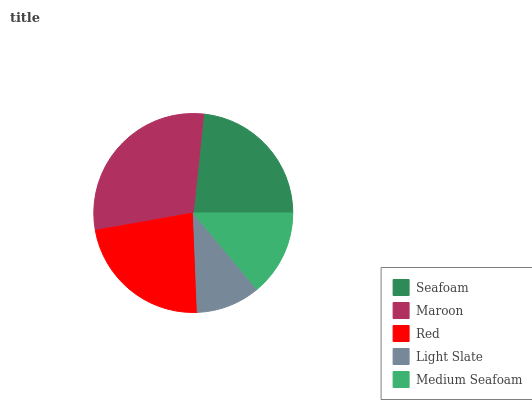Is Light Slate the minimum?
Answer yes or no. Yes. Is Maroon the maximum?
Answer yes or no. Yes. Is Red the minimum?
Answer yes or no. No. Is Red the maximum?
Answer yes or no. No. Is Maroon greater than Red?
Answer yes or no. Yes. Is Red less than Maroon?
Answer yes or no. Yes. Is Red greater than Maroon?
Answer yes or no. No. Is Maroon less than Red?
Answer yes or no. No. Is Red the high median?
Answer yes or no. Yes. Is Red the low median?
Answer yes or no. Yes. Is Medium Seafoam the high median?
Answer yes or no. No. Is Maroon the low median?
Answer yes or no. No. 